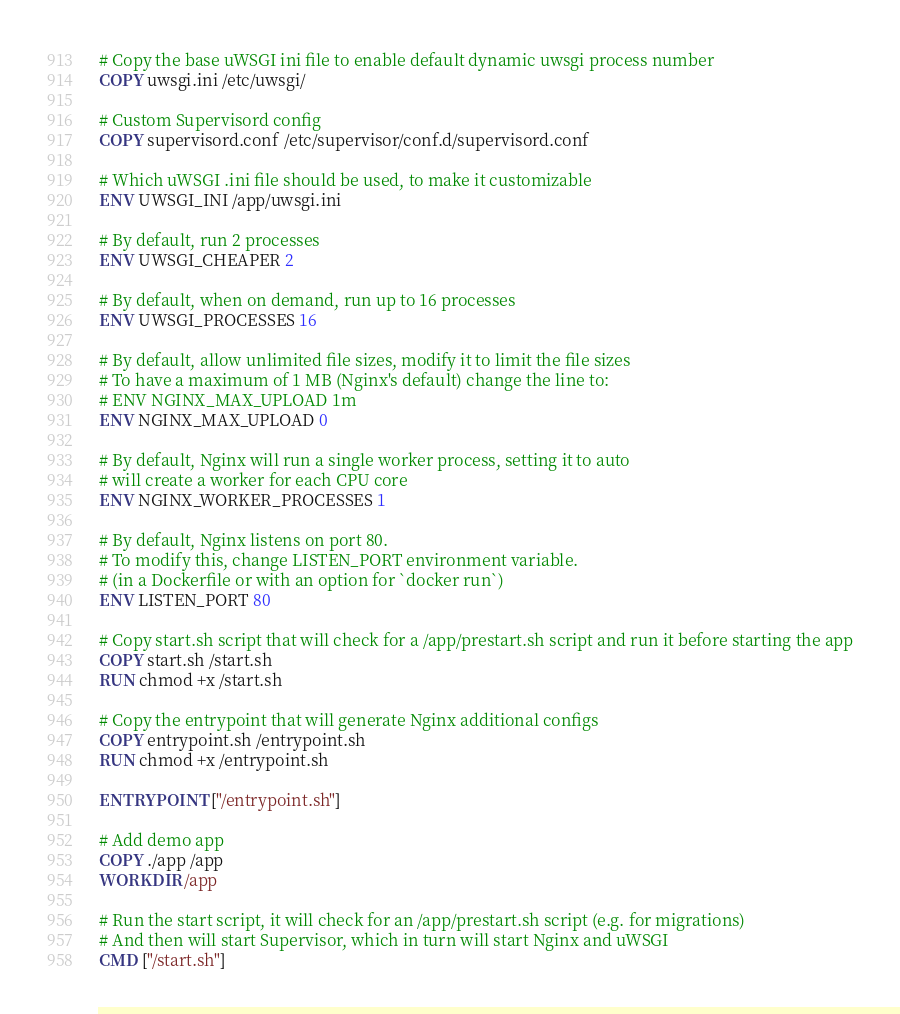<code> <loc_0><loc_0><loc_500><loc_500><_Dockerfile_># Copy the base uWSGI ini file to enable default dynamic uwsgi process number
COPY uwsgi.ini /etc/uwsgi/

# Custom Supervisord config
COPY supervisord.conf /etc/supervisor/conf.d/supervisord.conf

# Which uWSGI .ini file should be used, to make it customizable
ENV UWSGI_INI /app/uwsgi.ini

# By default, run 2 processes
ENV UWSGI_CHEAPER 2

# By default, when on demand, run up to 16 processes
ENV UWSGI_PROCESSES 16

# By default, allow unlimited file sizes, modify it to limit the file sizes
# To have a maximum of 1 MB (Nginx's default) change the line to:
# ENV NGINX_MAX_UPLOAD 1m
ENV NGINX_MAX_UPLOAD 0

# By default, Nginx will run a single worker process, setting it to auto
# will create a worker for each CPU core
ENV NGINX_WORKER_PROCESSES 1

# By default, Nginx listens on port 80.
# To modify this, change LISTEN_PORT environment variable.
# (in a Dockerfile or with an option for `docker run`)
ENV LISTEN_PORT 80

# Copy start.sh script that will check for a /app/prestart.sh script and run it before starting the app
COPY start.sh /start.sh
RUN chmod +x /start.sh

# Copy the entrypoint that will generate Nginx additional configs
COPY entrypoint.sh /entrypoint.sh
RUN chmod +x /entrypoint.sh

ENTRYPOINT ["/entrypoint.sh"]

# Add demo app
COPY ./app /app
WORKDIR /app

# Run the start script, it will check for an /app/prestart.sh script (e.g. for migrations)
# And then will start Supervisor, which in turn will start Nginx and uWSGI
CMD ["/start.sh"]
</code> 